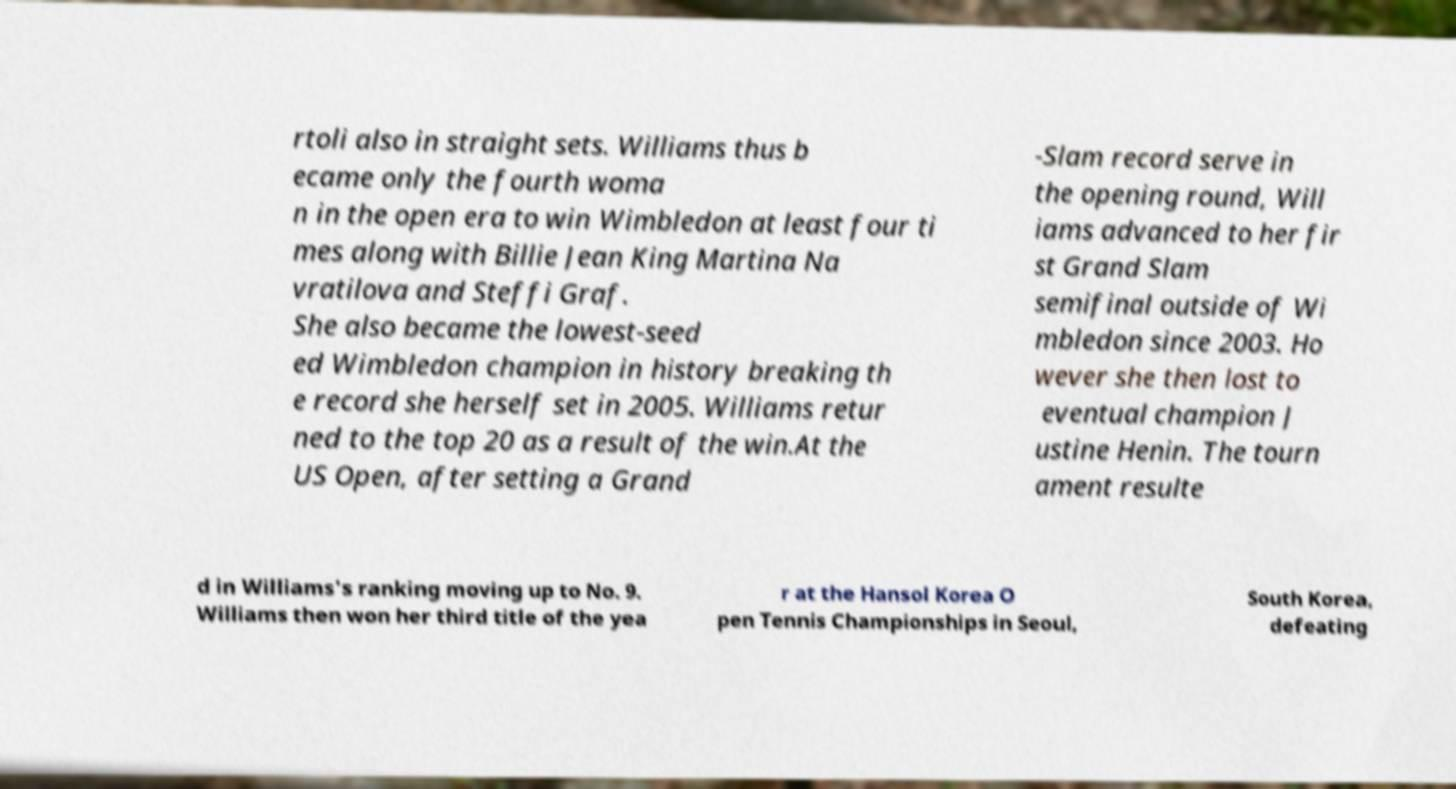Could you assist in decoding the text presented in this image and type it out clearly? rtoli also in straight sets. Williams thus b ecame only the fourth woma n in the open era to win Wimbledon at least four ti mes along with Billie Jean King Martina Na vratilova and Steffi Graf. She also became the lowest-seed ed Wimbledon champion in history breaking th e record she herself set in 2005. Williams retur ned to the top 20 as a result of the win.At the US Open, after setting a Grand -Slam record serve in the opening round, Will iams advanced to her fir st Grand Slam semifinal outside of Wi mbledon since 2003. Ho wever she then lost to eventual champion J ustine Henin. The tourn ament resulte d in Williams's ranking moving up to No. 9. Williams then won her third title of the yea r at the Hansol Korea O pen Tennis Championships in Seoul, South Korea, defeating 